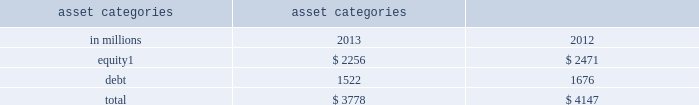Management 2019s discussion and analysis sensitivity measures certain portfolios and individual positions are not included in var because var is not the most appropriate risk measure .
Other sensitivity measures we use to analyze market risk are described below .
10% ( 10 % ) sensitivity measures .
The table below presents market risk for inventory positions that are not included in var .
The market risk of these positions is determined by estimating the potential reduction in net revenues of a 10% ( 10 % ) decline in the underlying asset value .
Equity positions below relate to private and restricted public equity securities , including interests in funds that invest in corporate equities and real estate and interests in hedge funds , which are included in 201cfinancial instruments owned , at fair value . 201d debt positions include interests in funds that invest in corporate mezzanine and senior debt instruments , loans backed by commercial and residential real estate , corporate bank loans and other corporate debt , including acquired portfolios of distressed loans .
These debt positions are included in 201cfinancial instruments owned , at fair value . 201d see note 6 to the consolidated financial statements for further information about cash instruments .
These measures do not reflect diversification benefits across asset categories or across other market risk measures .
Asset categories 10% ( 10 % ) sensitivity amount as of december in millions 2013 2012 equity 1 $ 2256 $ 2471 .
December 2012 includes $ 208 million related to our investment in the ordinary shares of icbc , which was sold in the first half of 2013 .
Credit spread sensitivity on derivatives and borrowings .
Var excludes the impact of changes in counterparty and our own credit spreads on derivatives as well as changes in our own credit spreads on unsecured borrowings for which the fair value option was elected .
The estimated sensitivity to a one basis point increase in credit spreads ( counterparty and our own ) on derivatives was a gain of $ 4 million and $ 3 million ( including hedges ) as of december 2013 and december 2012 , respectively .
In addition , the estimated sensitivity to a one basis point increase in our own credit spreads on unsecured borrowings for which the fair value option was elected was a gain of $ 8 million and $ 7 million ( including hedges ) as of december 2013 and december 2012 , respectively .
However , the actual net impact of a change in our own credit spreads is also affected by the liquidity , duration and convexity ( as the sensitivity is not linear to changes in yields ) of those unsecured borrowings for which the fair value option was elected , as well as the relative performance of any hedges undertaken .
Interest rate sensitivity .
As of december 2013 and december 2012 , the firm had $ 14.90 billion and $ 6.50 billion , respectively , of loans held for investment which were accounted for at amortized cost and included in 201creceivables from customers and counterparties , 201d substantially all of which had floating interest rates .
As of december 2013 and december 2012 , the estimated sensitivity to a 100 basis point increase in interest rates on such loans was $ 136 million and $ 62 million , respectively , of additional interest income over a 12-month period , which does not take into account the potential impact of an increase in costs to fund such loans .
See note 8 to the consolidated financial statements for further information about loans held for investment .
Goldman sachs 2013 annual report 95 .
What was the average estimated sensitivity to a one basis point increase in credit spreads ( counterparty and our own ) on derivatives in millions for the years of december 2013 and december 2012? 
Computations: ((4 + 3) / 2)
Answer: 3.5. 